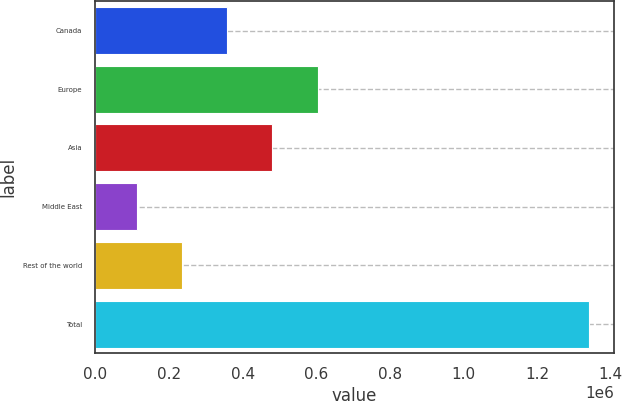Convert chart. <chart><loc_0><loc_0><loc_500><loc_500><bar_chart><fcel>Canada<fcel>Europe<fcel>Asia<fcel>Middle East<fcel>Rest of the world<fcel>Total<nl><fcel>358215<fcel>603952<fcel>481083<fcel>112478<fcel>235346<fcel>1.34116e+06<nl></chart> 